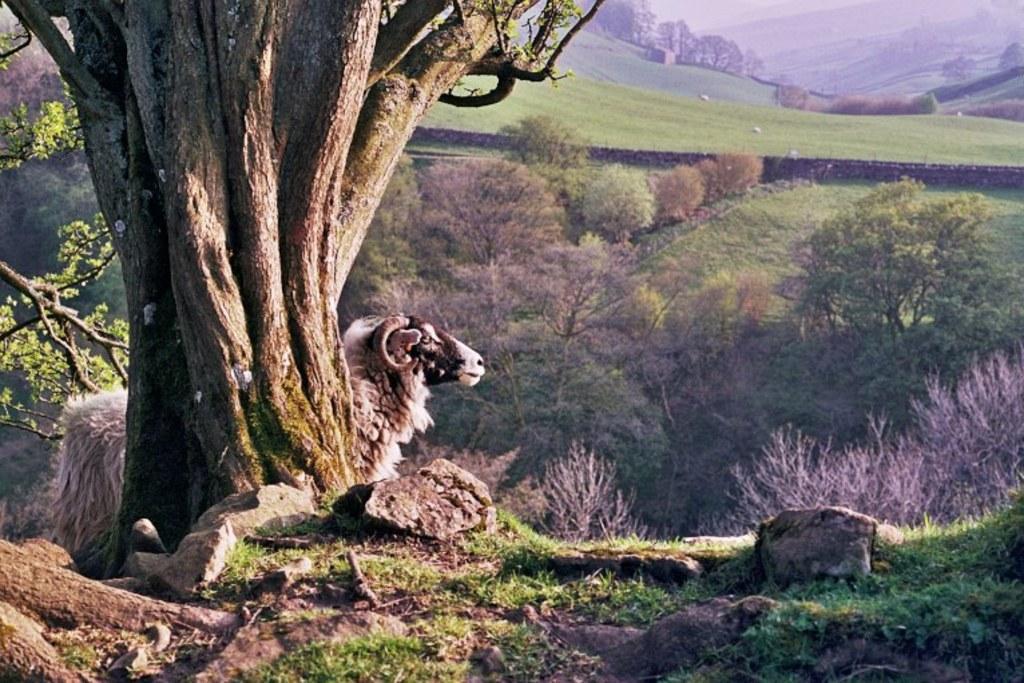Please provide a concise description of this image. In this picture we can see an animal and few stones and in the background we can see trees. 